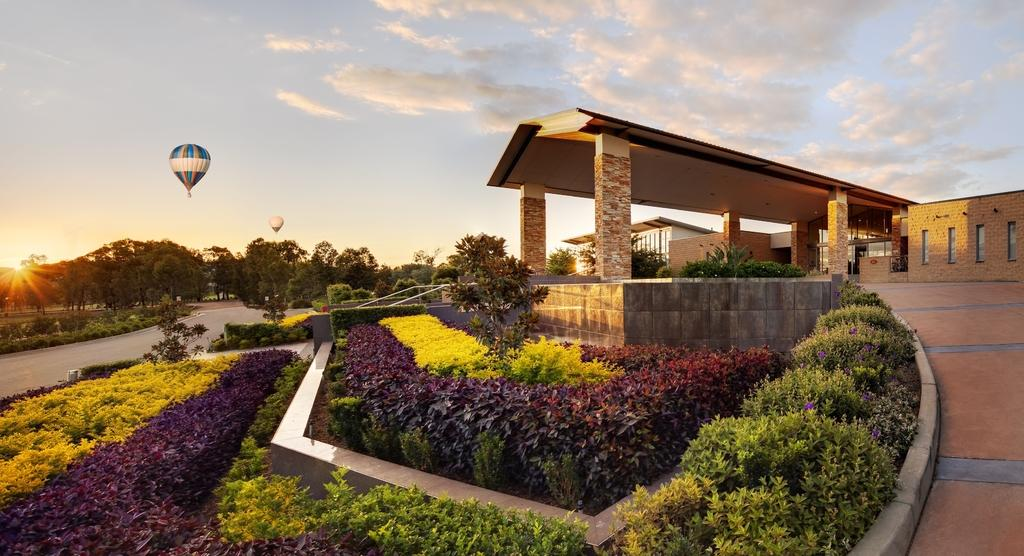What type of structures can be seen in the image? There are buildings in the image. What other natural elements are present in the image? There are plants and trees in the image. What is the condition of the sky in the image? The sun is visible in the sky. What type of poisonous plant can be seen in the image? There is no poisonous plant present in the image; only plants and trees are visible. What type of wealth can be seen in the image? There is no wealth present in the image; it features buildings, plants, trees, and the sun. 